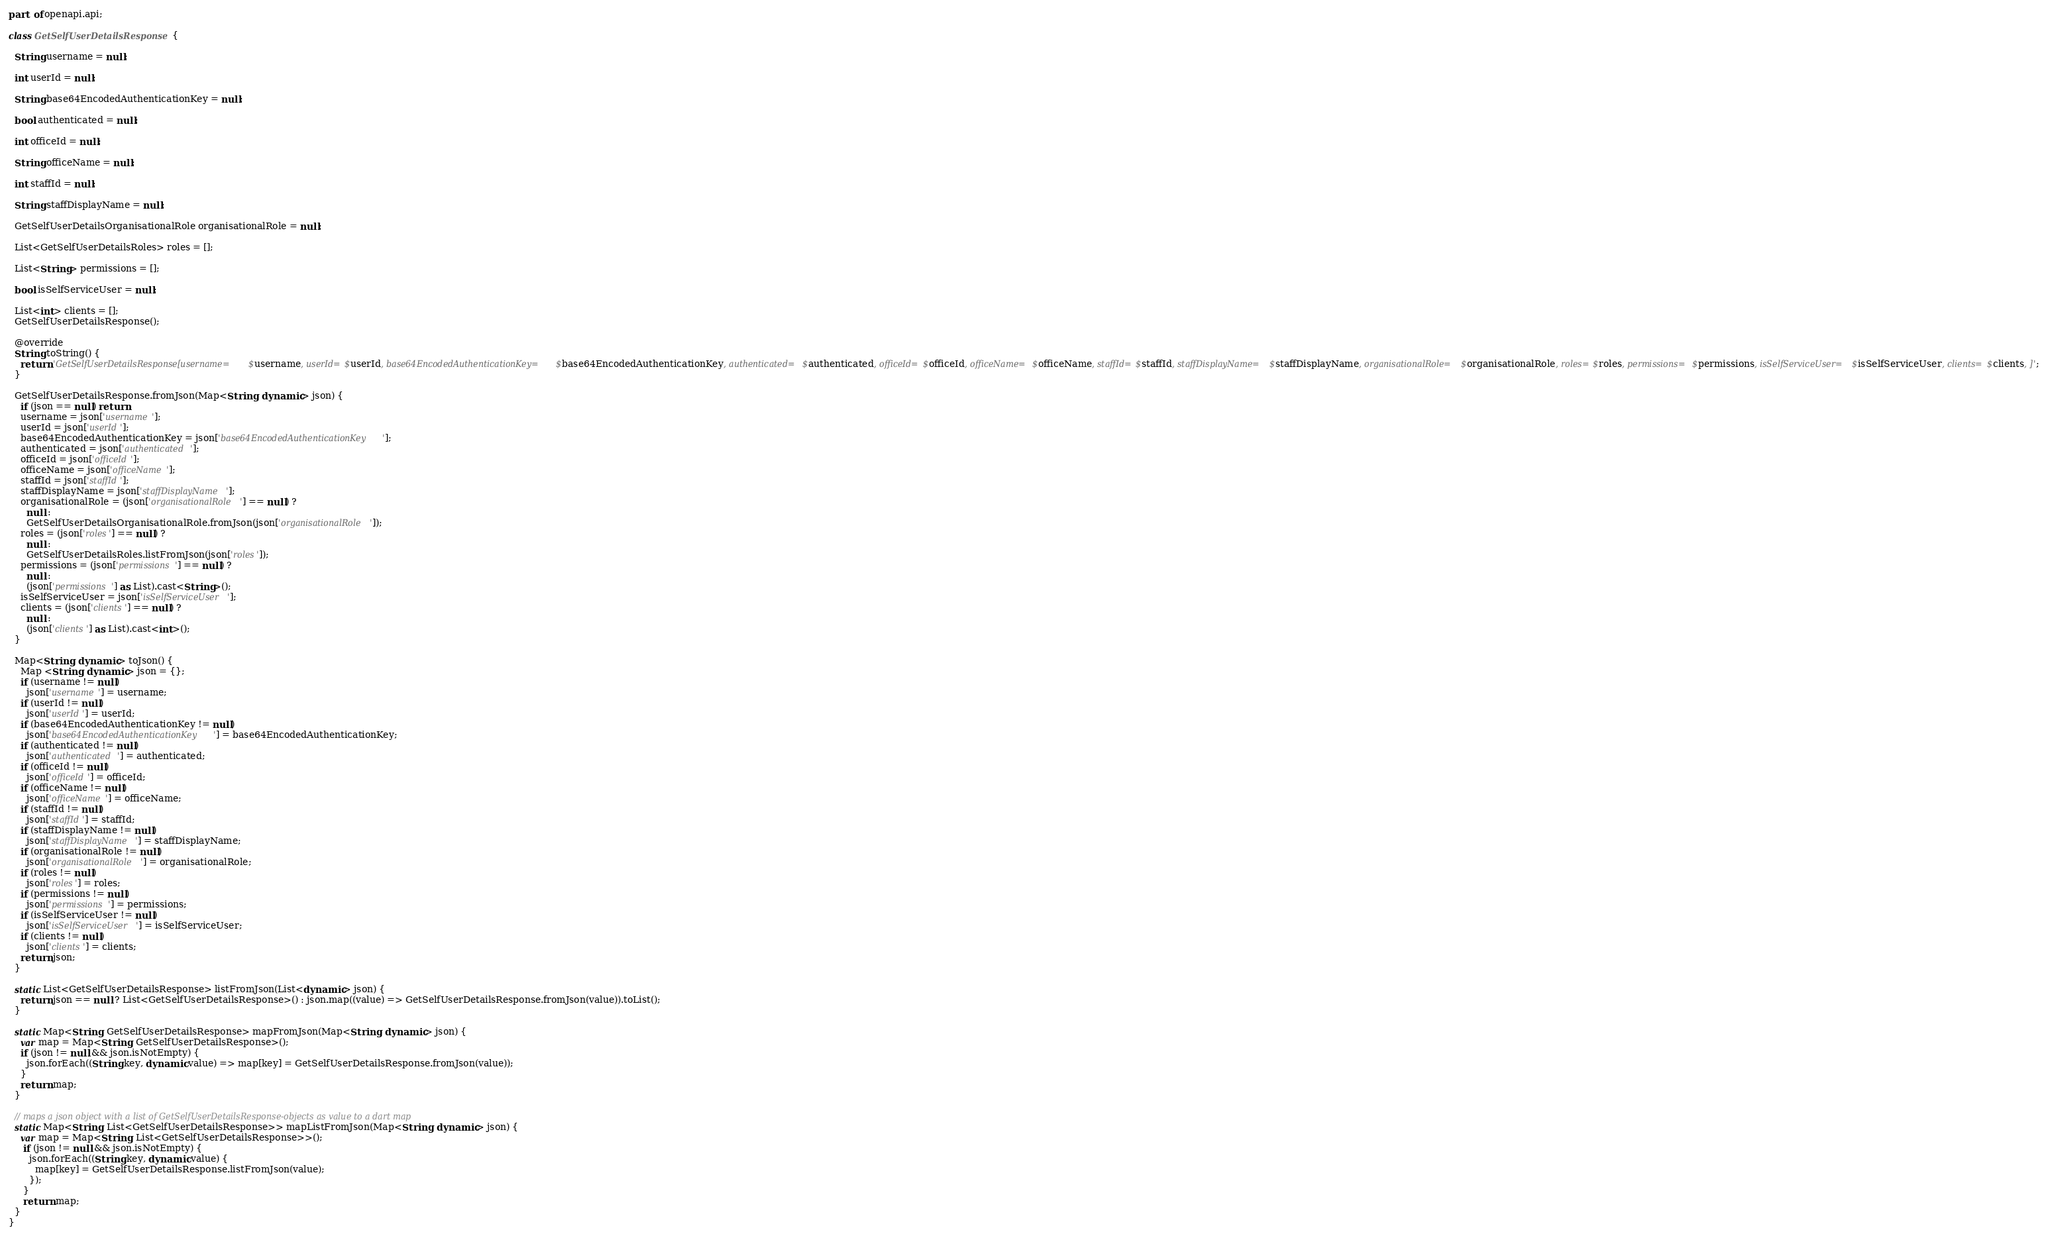<code> <loc_0><loc_0><loc_500><loc_500><_Dart_>part of openapi.api;

class GetSelfUserDetailsResponse {
  
  String username = null;
  
  int userId = null;
  
  String base64EncodedAuthenticationKey = null;
  
  bool authenticated = null;
  
  int officeId = null;
  
  String officeName = null;
  
  int staffId = null;
  
  String staffDisplayName = null;
  
  GetSelfUserDetailsOrganisationalRole organisationalRole = null;
  
  List<GetSelfUserDetailsRoles> roles = [];
  
  List<String> permissions = [];
  
  bool isSelfServiceUser = null;
  
  List<int> clients = [];
  GetSelfUserDetailsResponse();

  @override
  String toString() {
    return 'GetSelfUserDetailsResponse[username=$username, userId=$userId, base64EncodedAuthenticationKey=$base64EncodedAuthenticationKey, authenticated=$authenticated, officeId=$officeId, officeName=$officeName, staffId=$staffId, staffDisplayName=$staffDisplayName, organisationalRole=$organisationalRole, roles=$roles, permissions=$permissions, isSelfServiceUser=$isSelfServiceUser, clients=$clients, ]';
  }

  GetSelfUserDetailsResponse.fromJson(Map<String, dynamic> json) {
    if (json == null) return;
    username = json['username'];
    userId = json['userId'];
    base64EncodedAuthenticationKey = json['base64EncodedAuthenticationKey'];
    authenticated = json['authenticated'];
    officeId = json['officeId'];
    officeName = json['officeName'];
    staffId = json['staffId'];
    staffDisplayName = json['staffDisplayName'];
    organisationalRole = (json['organisationalRole'] == null) ?
      null :
      GetSelfUserDetailsOrganisationalRole.fromJson(json['organisationalRole']);
    roles = (json['roles'] == null) ?
      null :
      GetSelfUserDetailsRoles.listFromJson(json['roles']);
    permissions = (json['permissions'] == null) ?
      null :
      (json['permissions'] as List).cast<String>();
    isSelfServiceUser = json['isSelfServiceUser'];
    clients = (json['clients'] == null) ?
      null :
      (json['clients'] as List).cast<int>();
  }

  Map<String, dynamic> toJson() {
    Map <String, dynamic> json = {};
    if (username != null)
      json['username'] = username;
    if (userId != null)
      json['userId'] = userId;
    if (base64EncodedAuthenticationKey != null)
      json['base64EncodedAuthenticationKey'] = base64EncodedAuthenticationKey;
    if (authenticated != null)
      json['authenticated'] = authenticated;
    if (officeId != null)
      json['officeId'] = officeId;
    if (officeName != null)
      json['officeName'] = officeName;
    if (staffId != null)
      json['staffId'] = staffId;
    if (staffDisplayName != null)
      json['staffDisplayName'] = staffDisplayName;
    if (organisationalRole != null)
      json['organisationalRole'] = organisationalRole;
    if (roles != null)
      json['roles'] = roles;
    if (permissions != null)
      json['permissions'] = permissions;
    if (isSelfServiceUser != null)
      json['isSelfServiceUser'] = isSelfServiceUser;
    if (clients != null)
      json['clients'] = clients;
    return json;
  }

  static List<GetSelfUserDetailsResponse> listFromJson(List<dynamic> json) {
    return json == null ? List<GetSelfUserDetailsResponse>() : json.map((value) => GetSelfUserDetailsResponse.fromJson(value)).toList();
  }

  static Map<String, GetSelfUserDetailsResponse> mapFromJson(Map<String, dynamic> json) {
    var map = Map<String, GetSelfUserDetailsResponse>();
    if (json != null && json.isNotEmpty) {
      json.forEach((String key, dynamic value) => map[key] = GetSelfUserDetailsResponse.fromJson(value));
    }
    return map;
  }

  // maps a json object with a list of GetSelfUserDetailsResponse-objects as value to a dart map
  static Map<String, List<GetSelfUserDetailsResponse>> mapListFromJson(Map<String, dynamic> json) {
    var map = Map<String, List<GetSelfUserDetailsResponse>>();
     if (json != null && json.isNotEmpty) {
       json.forEach((String key, dynamic value) {
         map[key] = GetSelfUserDetailsResponse.listFromJson(value);
       });
     }
     return map;
  }
}

</code> 